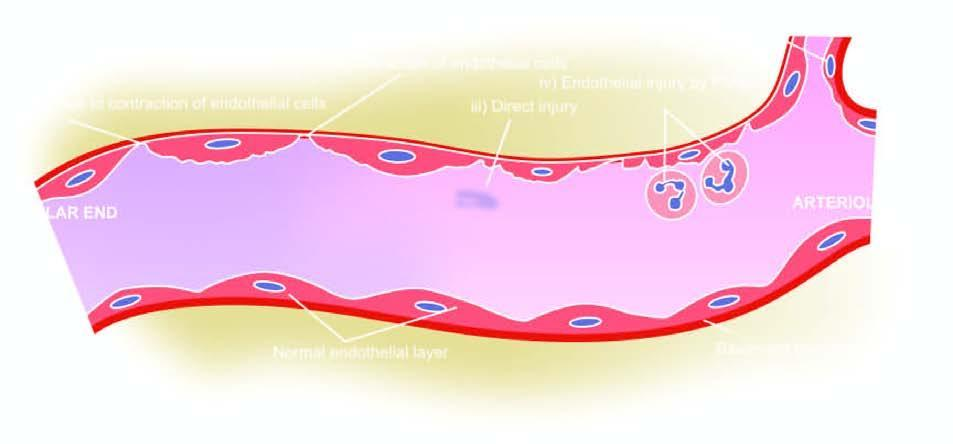what correspond to five numbers in the text?
Answer the question using a single word or phrase. The serial numbers in the figure 